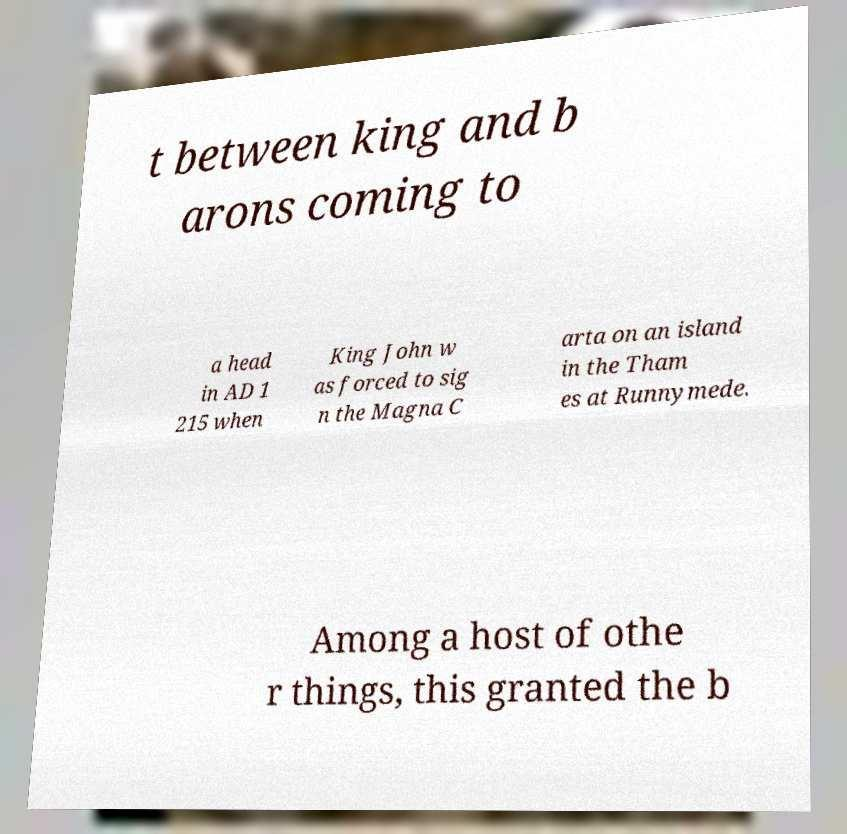Could you assist in decoding the text presented in this image and type it out clearly? t between king and b arons coming to a head in AD 1 215 when King John w as forced to sig n the Magna C arta on an island in the Tham es at Runnymede. Among a host of othe r things, this granted the b 